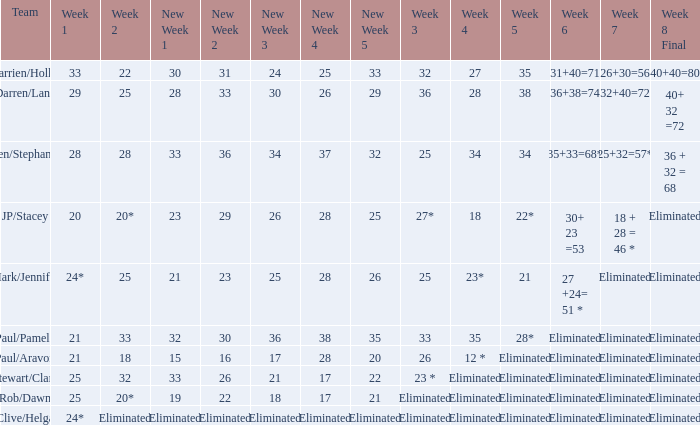Name the week 6 when week 3 is 25 and week 7 is eliminated 27 +24= 51 *. 